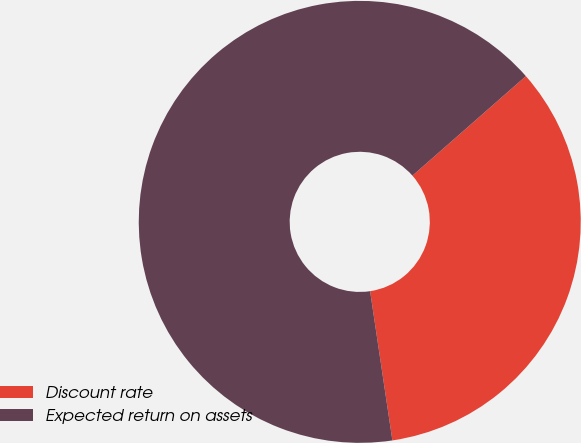<chart> <loc_0><loc_0><loc_500><loc_500><pie_chart><fcel>Discount rate<fcel>Expected return on assets<nl><fcel>34.1%<fcel>65.9%<nl></chart> 